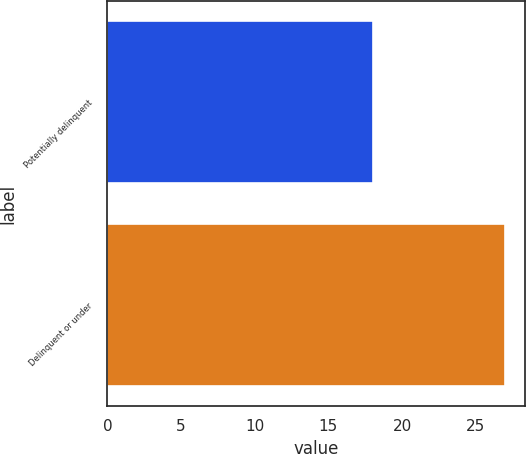Convert chart to OTSL. <chart><loc_0><loc_0><loc_500><loc_500><bar_chart><fcel>Potentially delinquent<fcel>Delinquent or under<nl><fcel>18<fcel>27<nl></chart> 